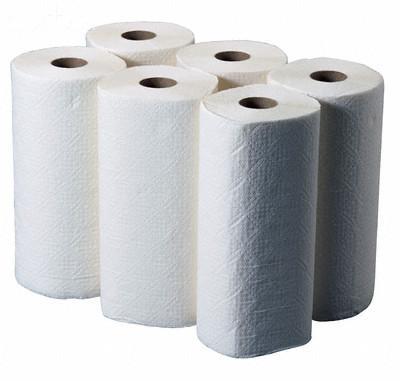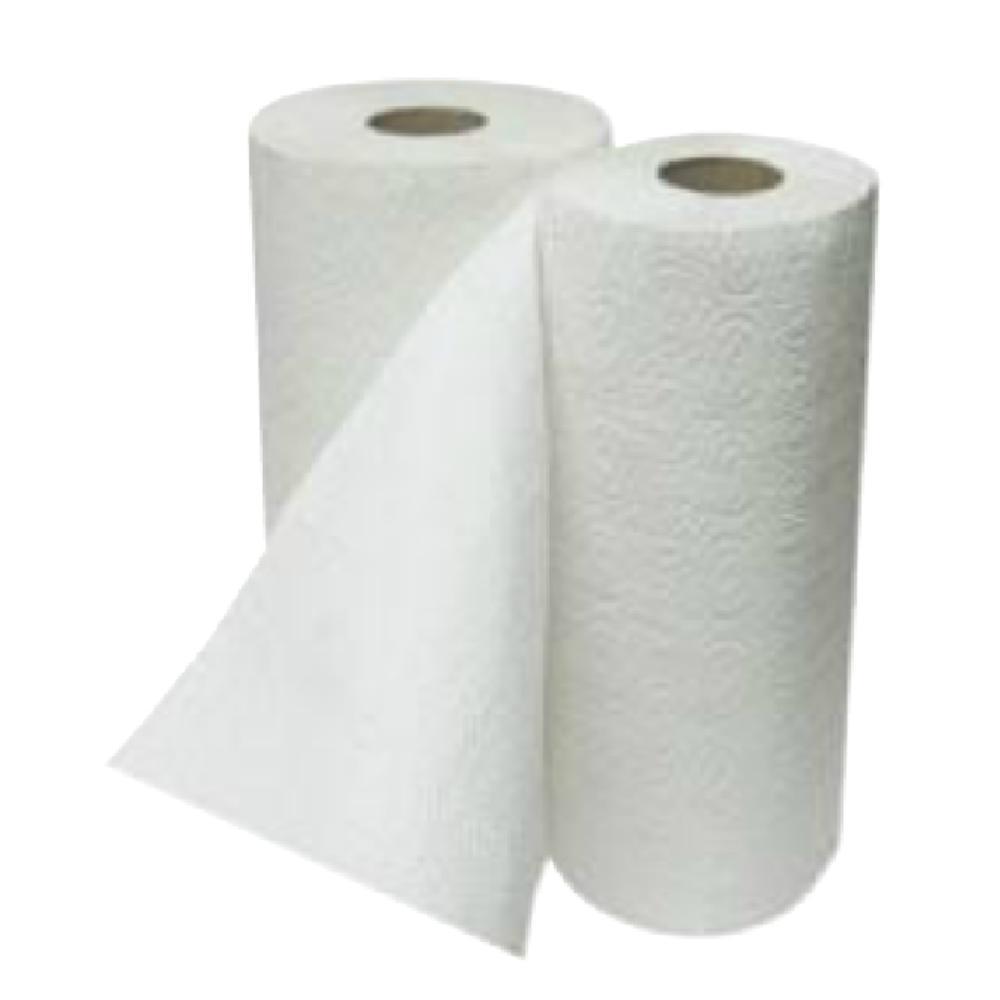The first image is the image on the left, the second image is the image on the right. Examine the images to the left and right. Is the description "The left and right images contain the same number of rolls." accurate? Answer yes or no. No. 